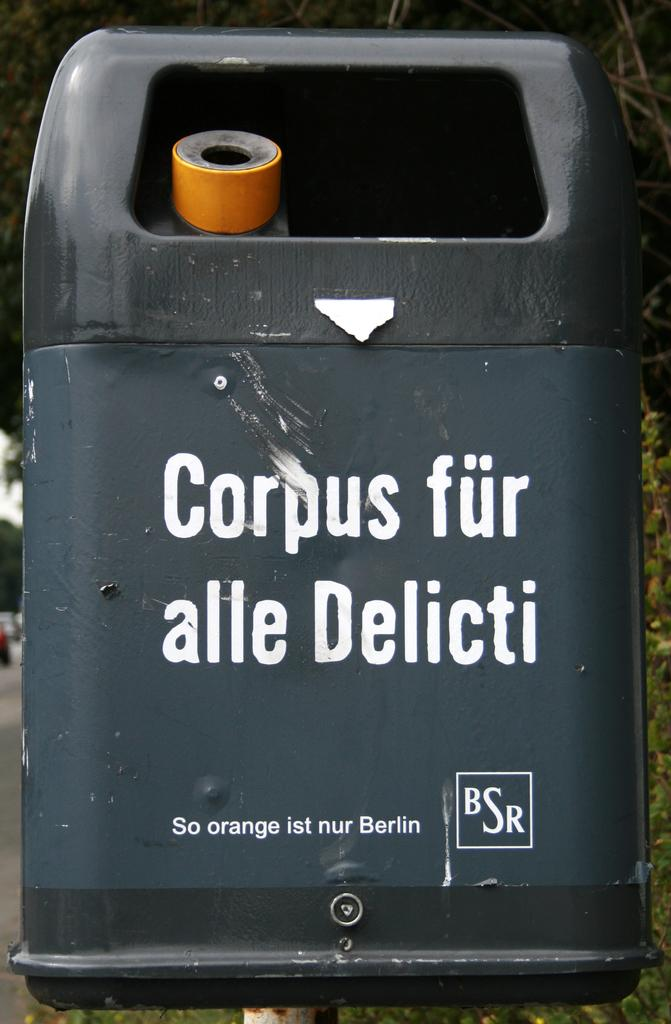Provide a one-sentence caption for the provided image. A back container has the words corpus fur alle delicti on the front. 